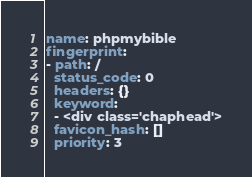<code> <loc_0><loc_0><loc_500><loc_500><_YAML_>name: phpmybible
fingerprint:
- path: /
  status_code: 0
  headers: {}
  keyword:
  - <div class='chaphead'>
  favicon_hash: []
  priority: 3
</code> 